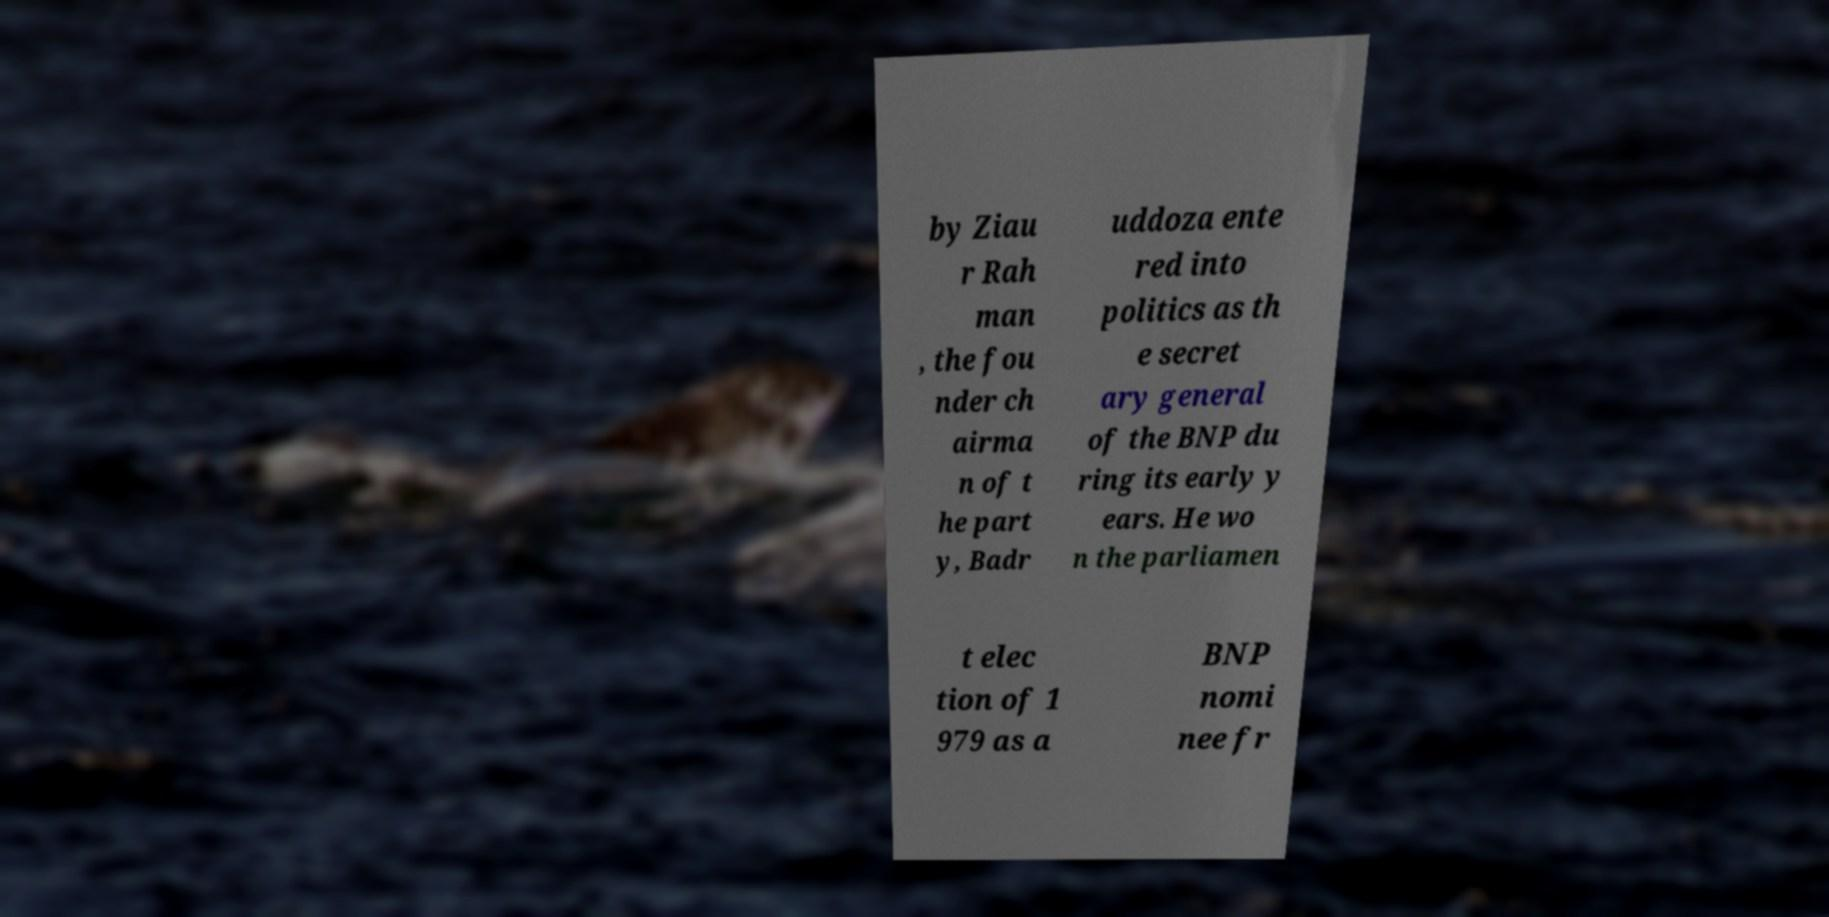What messages or text are displayed in this image? I need them in a readable, typed format. by Ziau r Rah man , the fou nder ch airma n of t he part y, Badr uddoza ente red into politics as th e secret ary general of the BNP du ring its early y ears. He wo n the parliamen t elec tion of 1 979 as a BNP nomi nee fr 